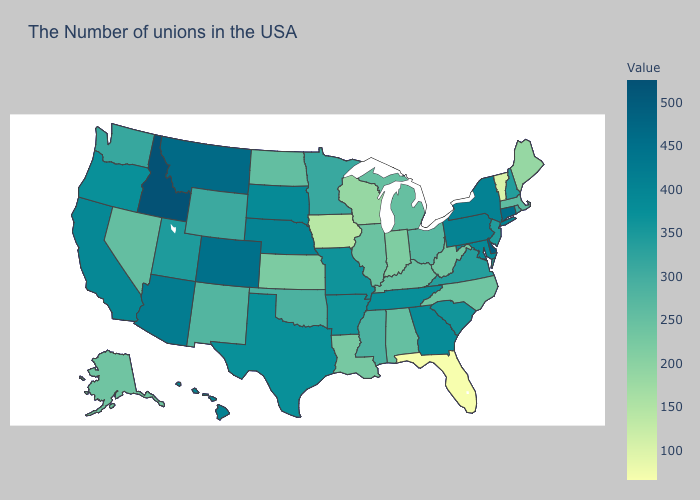Does Connecticut have the highest value in the Northeast?
Give a very brief answer. Yes. Does West Virginia have a higher value than South Dakota?
Quick response, please. No. Which states hav the highest value in the Northeast?
Be succinct. Connecticut. Among the states that border Connecticut , which have the highest value?
Write a very short answer. New York. Which states have the lowest value in the USA?
Be succinct. Florida. Is the legend a continuous bar?
Short answer required. Yes. Among the states that border Alabama , does Florida have the highest value?
Give a very brief answer. No. 